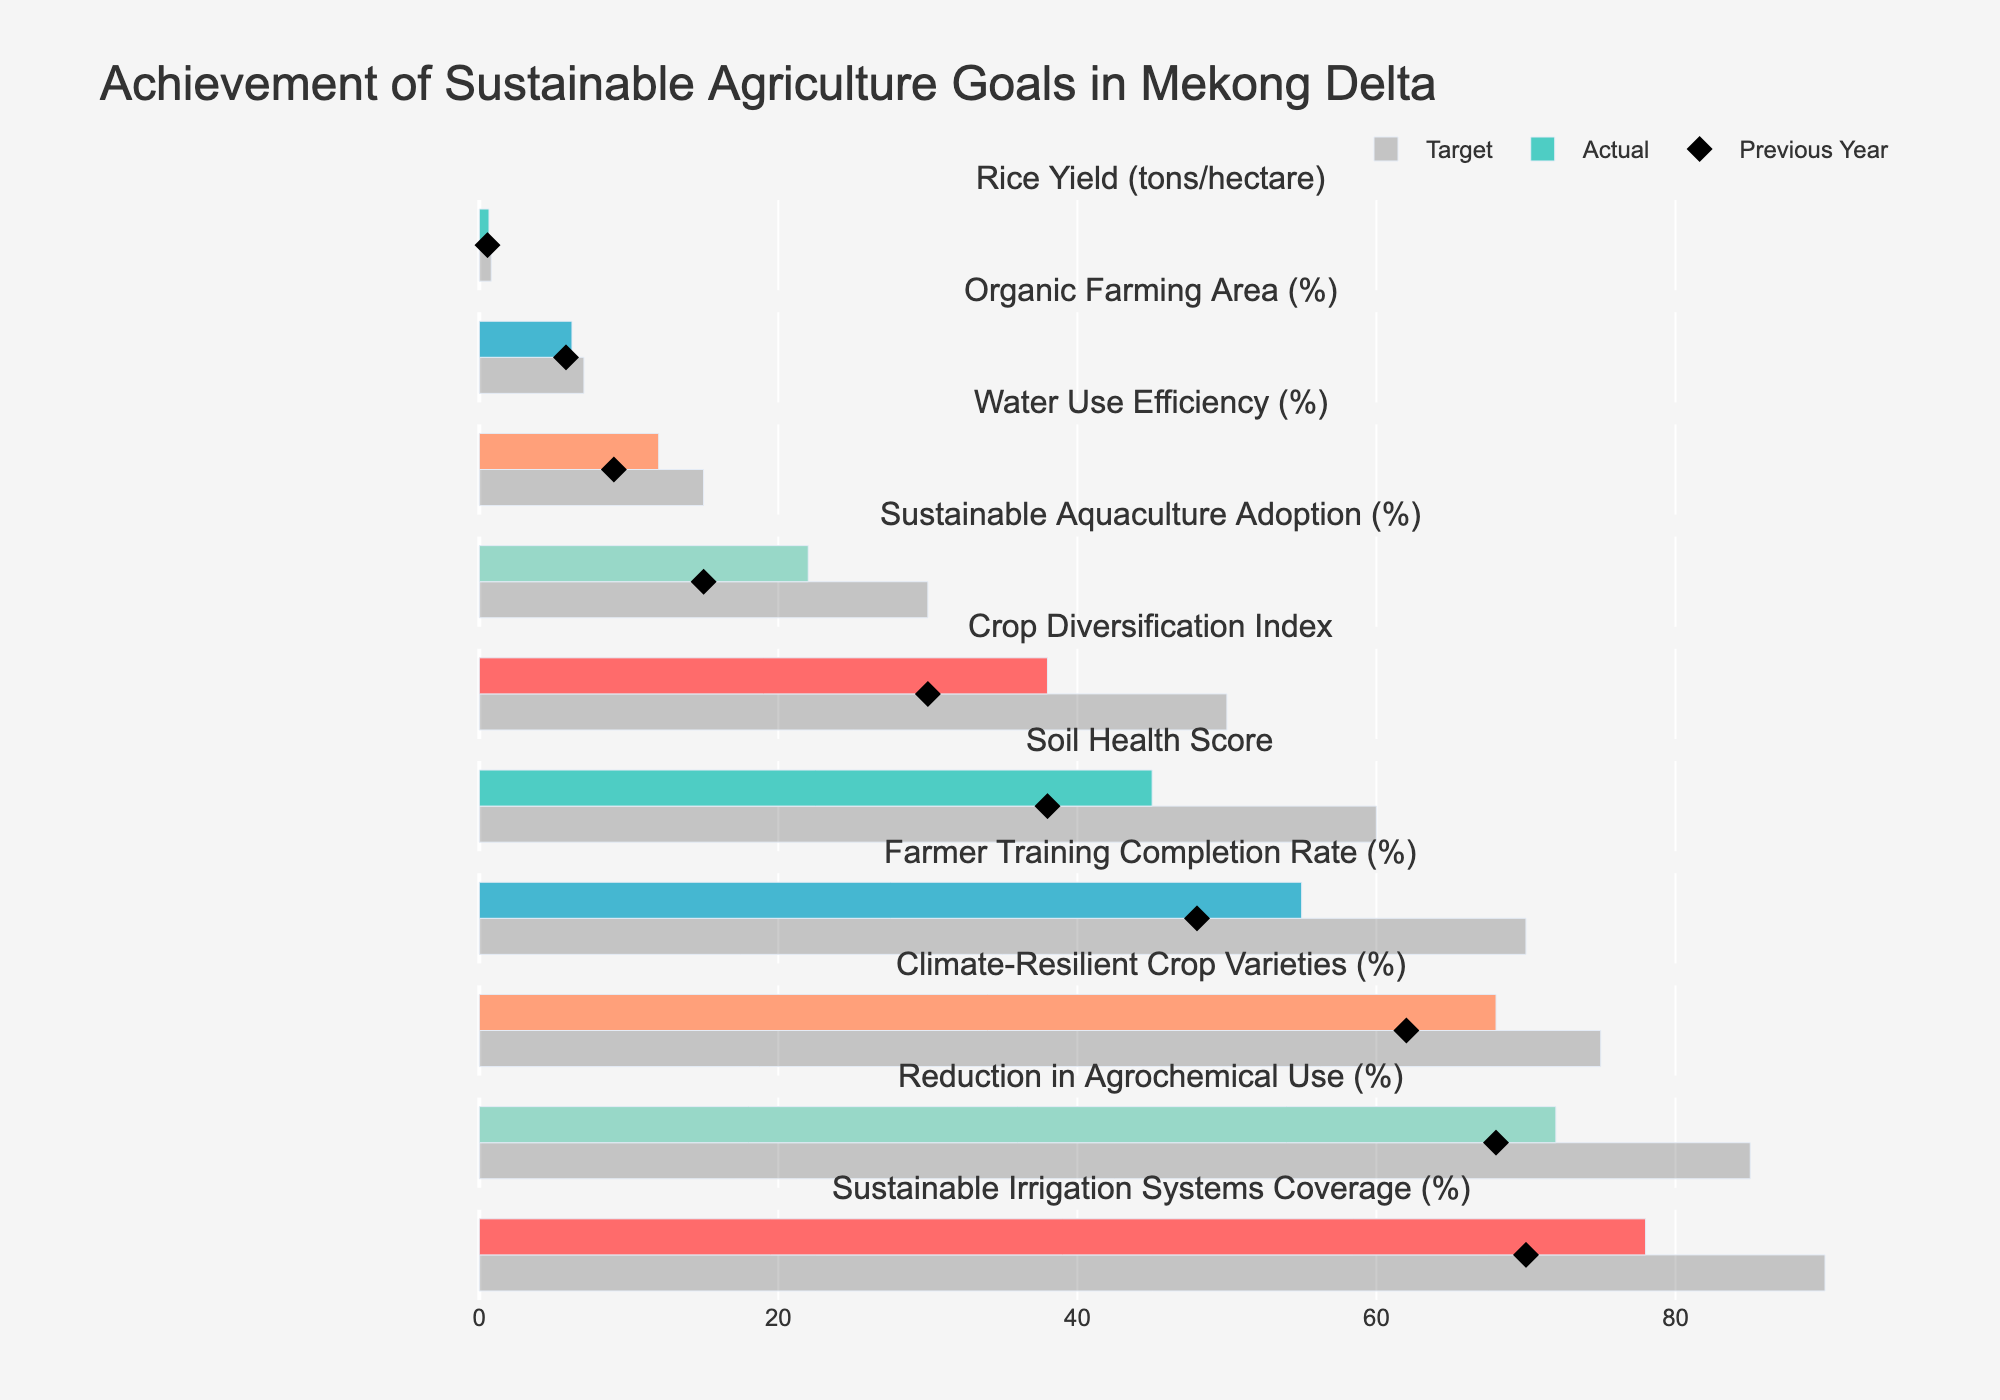How does the actual rice yield compare to the target? The actual rice yield is 6.2 tons/hectare, while the target is 7.0 tons/hectare. To compare, subtract the actual from the target: 7.0 - 6.2 = 0.8 tons/hectare lower.
Answer: 0.8 tons/hectare lower Is the percentage of Organic Farming Area increasing or decreasing compared to the Previous Year? The Previous Year value for Organic Farming Area is 9%, and the actual value is 12%. Since 12% is greater than 9%, it is increasing.
Answer: Increasing Which goal has the largest discrepancy between the target and the actual values? By calculating the differences between the targets and actuals for each metric, we find the largest discrepancy in Sustainable Aquaculture Adoption, with a target of 60% and an actual of 45%. The discrepancy is 60 - 45 = 15%.
Answer: Sustainable Aquaculture Adoption What is the actual value for Farmer Training Completion Rate compared to its target? The actual value for Farmer Training Completion Rate is 78%, while the target is 90%. To compare: 90 - 78 = 12% short of the target.
Answer: 12% short of the target How did Water Use Efficiency change from the previous year to the actual year? The Previous Year value for Water Use Efficiency is 62%, and the actual value is 68%. The change is calculated as 68 - 62 = 6% increase.
Answer: 6% increase Which metric has the closest actual value to its target? By inspecting each metric, Sustainable Irrigation Systems Coverage has the closest actual value to its target: Actual 55% vs Target 70%, resulting in a difference of 15%. This is the smallest discrepancy among all metrics.
Answer: Sustainable Irrigation Systems Coverage What is the average actual value across all metrics? Sum all actual values (6.2 + 12 + 68 + 45 + 0.65 + 72 + 78 + 38 + 22 + 55) = 396.85. Divide by the number of metrics (10): 396.85 / 10 = 39.685.
Answer: 39.69 How did the Soil Health Score change from the previous year to the actual year? The Previous Year value for Soil Health Score is 68, and the actual value is 72. The change is 72 - 68 = 4 points increase.
Answer: 4 points increase Which metric had the most improvement from the previous year to the actual year? Comparing the deltas for each metric, Sustainable Aquaculture Adoption improved from 38% to 45%, accounting for a 7% increase, which is the highest among metrics with absolute changes calculated.
Answer: Sustainable Aquaculture Adoption 